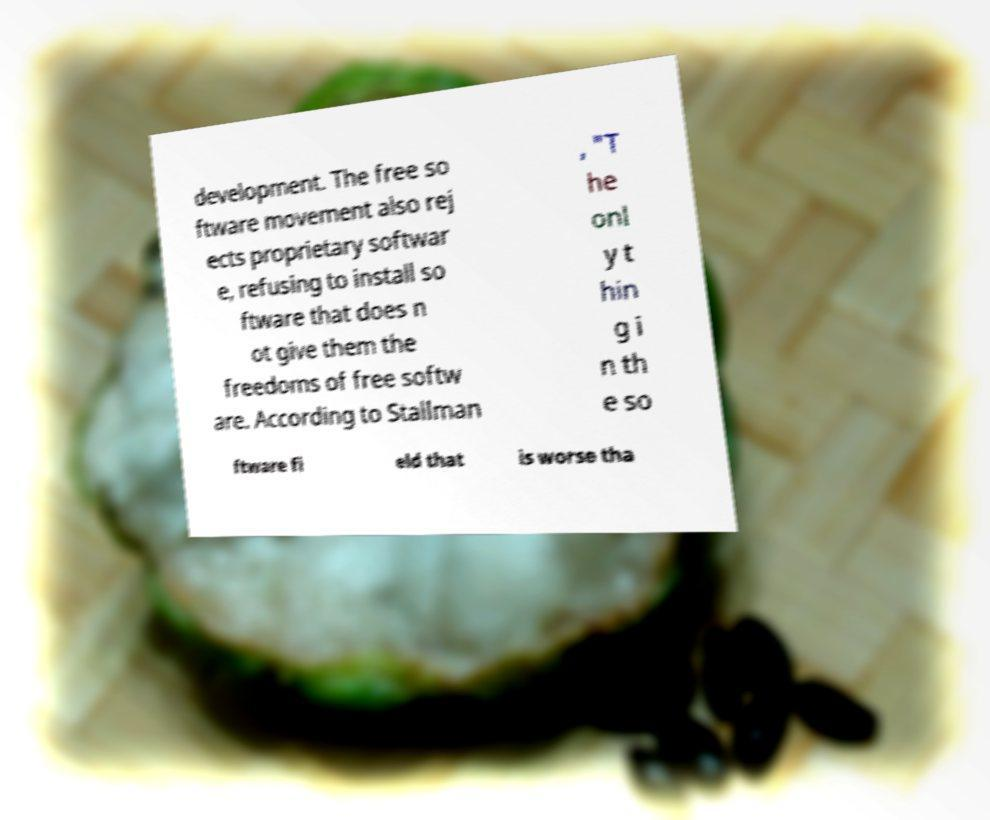I need the written content from this picture converted into text. Can you do that? development. The free so ftware movement also rej ects proprietary softwar e, refusing to install so ftware that does n ot give them the freedoms of free softw are. According to Stallman , "T he onl y t hin g i n th e so ftware fi eld that is worse tha 